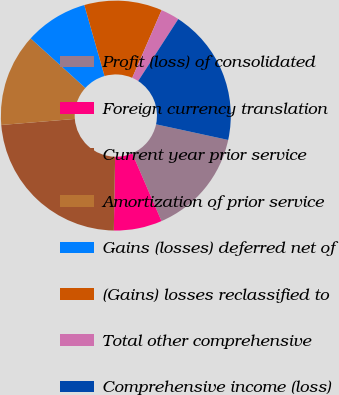Convert chart to OTSL. <chart><loc_0><loc_0><loc_500><loc_500><pie_chart><fcel>Profit (loss) of consolidated<fcel>Foreign currency translation<fcel>Current year prior service<fcel>Amortization of prior service<fcel>Gains (losses) deferred net of<fcel>(Gains) losses reclassified to<fcel>Total other comprehensive<fcel>Comprehensive income (loss)<nl><fcel>15.1%<fcel>6.78%<fcel>23.42%<fcel>13.02%<fcel>8.86%<fcel>10.94%<fcel>2.62%<fcel>19.26%<nl></chart> 